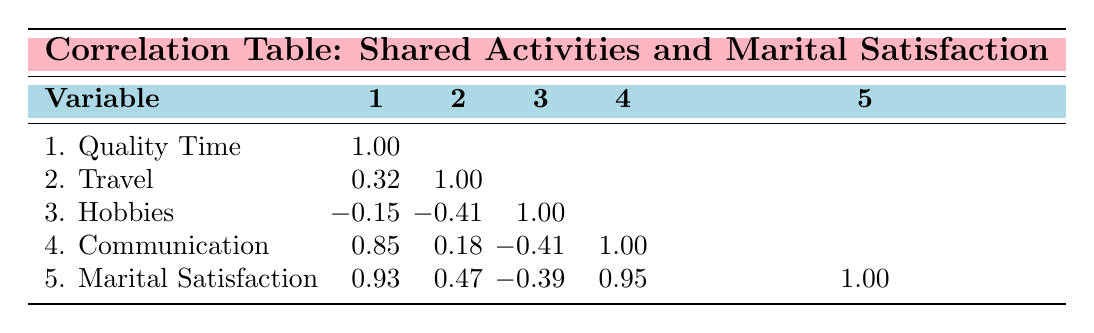What is the correlation between Quality Time and Marital Satisfaction? The correlation value between Quality Time and Marital Satisfaction is 0.93 as indicated in the table. This indicates a strong positive relationship, suggesting that as Quality Time increases, Marital Satisfaction tends to increase as well.
Answer: 0.93 Is there a positive correlation between Communication and Travel? The correlation value between Communication and Travel is 0.18, which suggests a weak positive relationship. This indicates that increases in Travel are only slightly associated with increases in Communication.
Answer: No What is the average correlation for all activities with Marital Satisfaction? The correlation values for activities with Marital Satisfaction are 0.93 (Quality Time), 0.47 (Travel), -0.39 (Hobbies), and 0.95 (Communication). We sum these values: 0.93 + 0.47 - 0.39 + 0.95 = 2.96, and divide by 4 (the number of activities) to find the average: 2.96 / 4 = 0.74.
Answer: 0.74 Which activity has the strongest negative correlation with Marital Satisfaction? The correlation values with Marital Satisfaction are: 0.93 (Quality Time), 0.47 (Travel), -0.39 (Hobbies), and 0.95 (Communication). The strongest negative correlation is -0.39 for Hobbies.
Answer: Hobbies Is it true that Communication is highly correlated with Marital Satisfaction? Yes, the correlation value between Communication and Marital Satisfaction is 0.95, indicating a very strong positive correlation. This means that as Communication improves, Marital Satisfaction is likely to improve as well.
Answer: Yes What is the difference in correlation between Quality Time and Communication? The correlation for Quality Time is 0.93 and for Communication is 0.95. The difference is calculated by subtracting: 0.95 - 0.93 = 0.02. This indicates that Communication has a slightly stronger correlation with Marital Satisfaction than Quality Time.
Answer: 0.02 